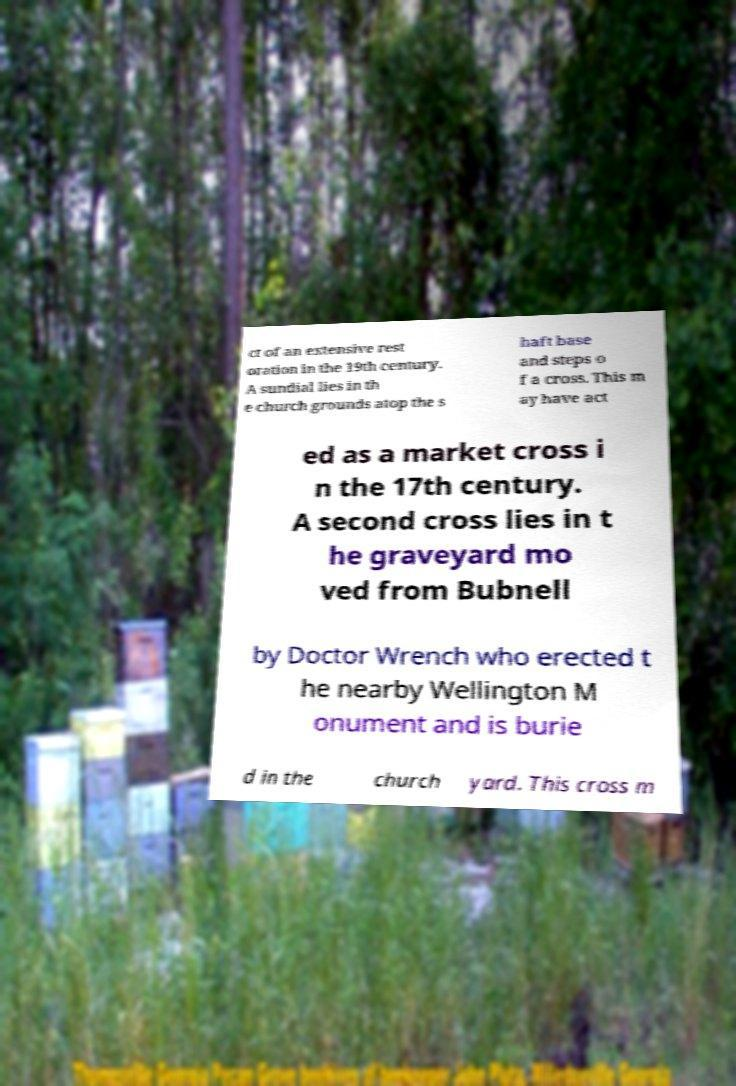Please identify and transcribe the text found in this image. ct of an extensive rest oration in the 19th century. A sundial lies in th e church grounds atop the s haft base and steps o f a cross. This m ay have act ed as a market cross i n the 17th century. A second cross lies in t he graveyard mo ved from Bubnell by Doctor Wrench who erected t he nearby Wellington M onument and is burie d in the church yard. This cross m 